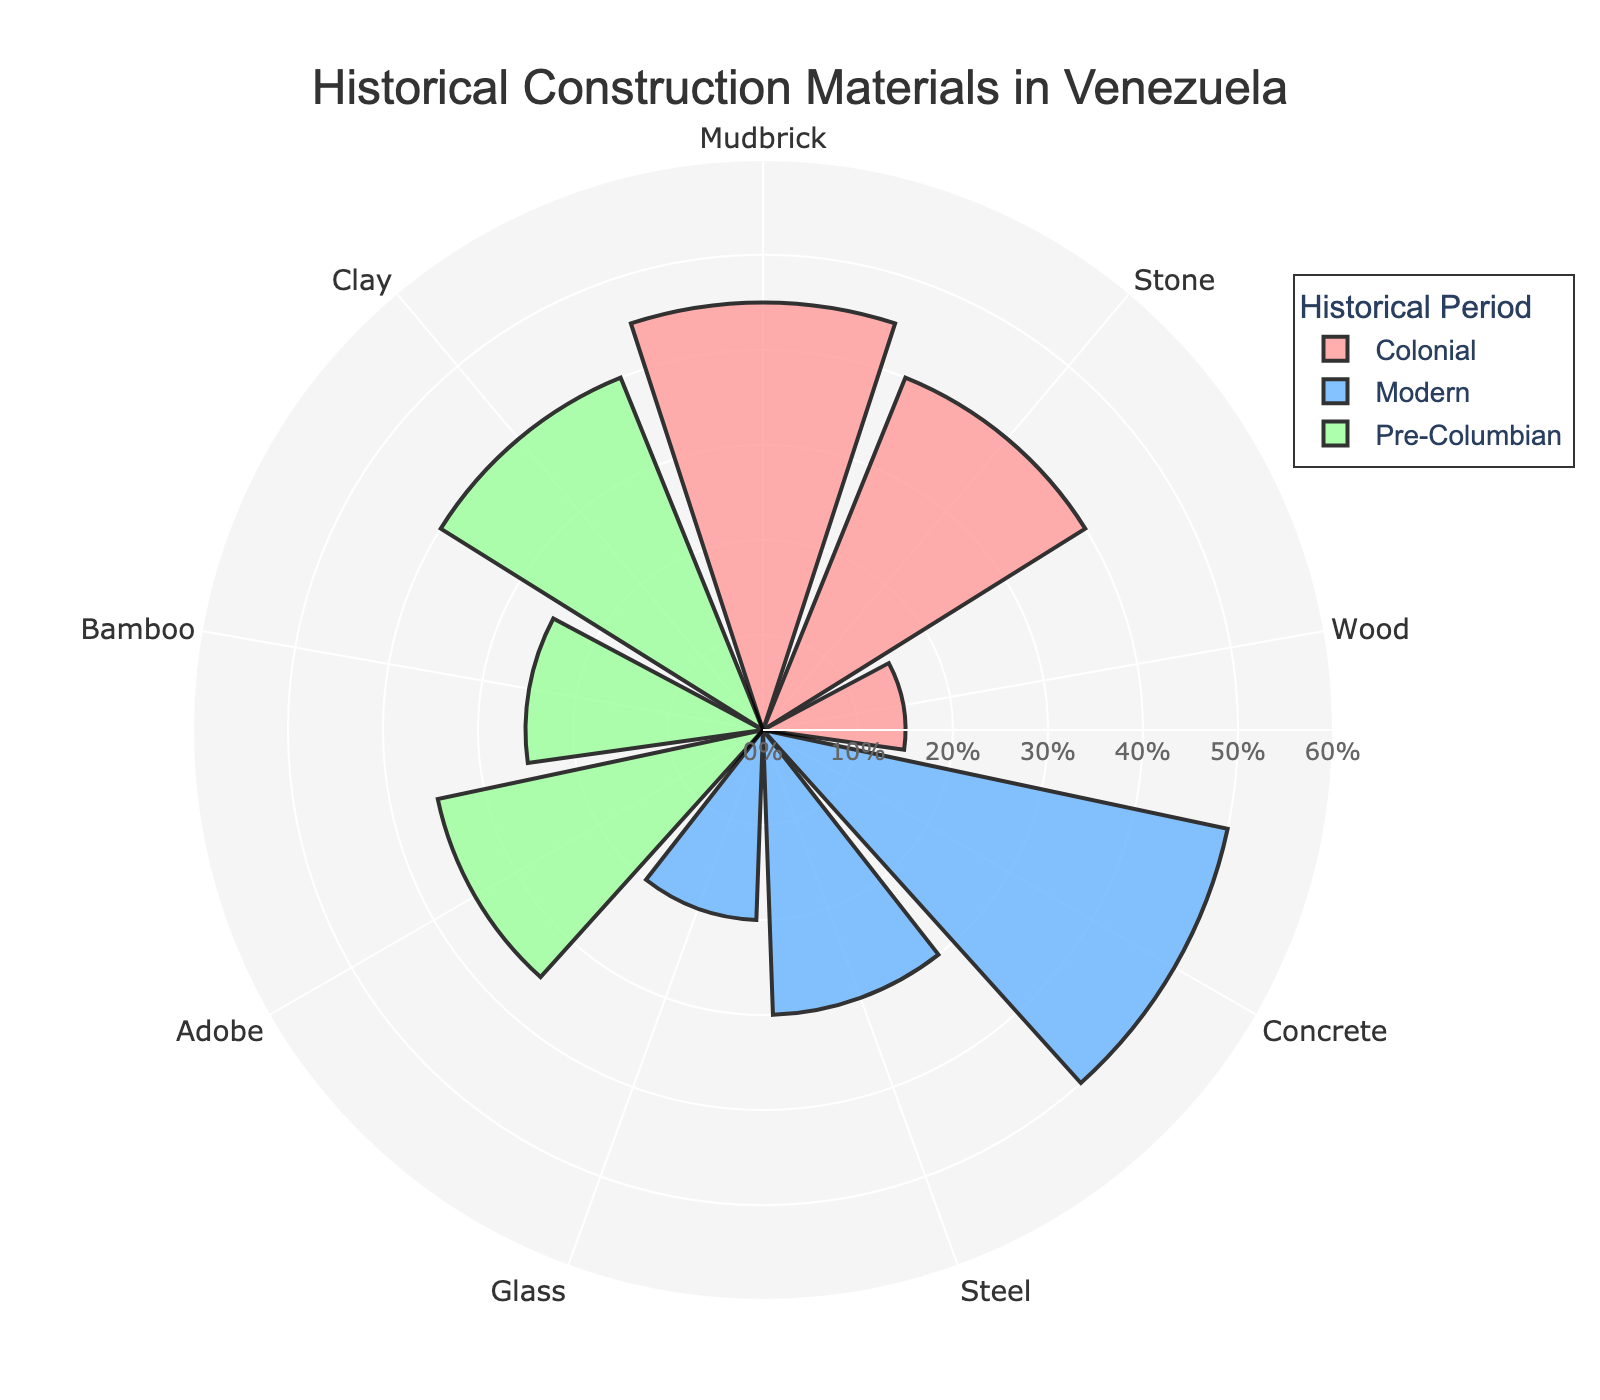What's the title of the rose chart? The title is usually displayed prominently at the top of the chart. In this case, it reads "Historical Construction Materials in Venezuela".
Answer: Historical Construction Materials in Venezuela How many historical periods are represented in the chart? The chart includes three distinct groups, which correspond to three historical periods. These are "Pre-Columbian", "Colonial", and "Modern".
Answer: Three Which material has the highest usage percentage in the Pre-Columbian period? By examining the "Pre-Columbian" section of the chart, the highest value is observed for Clay at 40%.
Answer: Clay What is the combined usage percentage of Stone and Wood during the Colonial period? In the Colonial period, Stone is at 40% and Wood is at 15%. Adding these percentages together gives 40% + 15% = 55%.
Answer: 55% How does the usage of Concrete in the Modern period compare to the usage of Adobe in the Pre-Columbian period? In the Modern period, Concrete is used 50%, whereas in the Pre-Columbian period, Adobe is used 35%. Comparing these values, Concrete usage is higher.
Answer: Concrete usage is higher Which period shows the least variety of construction materials? Variety is determined by the number of distinct materials listed. The Pre-Columbian and Modern periods both have three materials, while the Colonial period also has three materials. Thus, they all show the same variety.
Answer: Same variety across periods In which period is Glass used and what is its usage percentage? Glass is examined in the Modern period section where it is listed with a percentage of 20%.
Answer: Modern, 20% Comparing the usage percentages of Steel and Glass in the Modern period, which is more prevalent? By checking the Modern period portion of the chart, Steel usage is 30%, whereas Glass usage is 20%. Thus, Steel is more prevalent.
Answer: Steel What are the three materials used in the Colonial period and what are their usage percentages? For the Colonial period, the materials listed are Mudbrick (45%), Stone (40%), and Wood (15%). These values can be read directly from the chart.
Answer: Mudbrick: 45%, Stone: 40%, Wood: 15% What’s the usage percentage difference between Bamboo in the Pre-Columbian period and Steel in the Modern period? Bamboo in the Pre-Columbian period is 25% and Steel in the Modern period is 30%. The difference is calculated as 30% - 25% = 5%.
Answer: 5% 